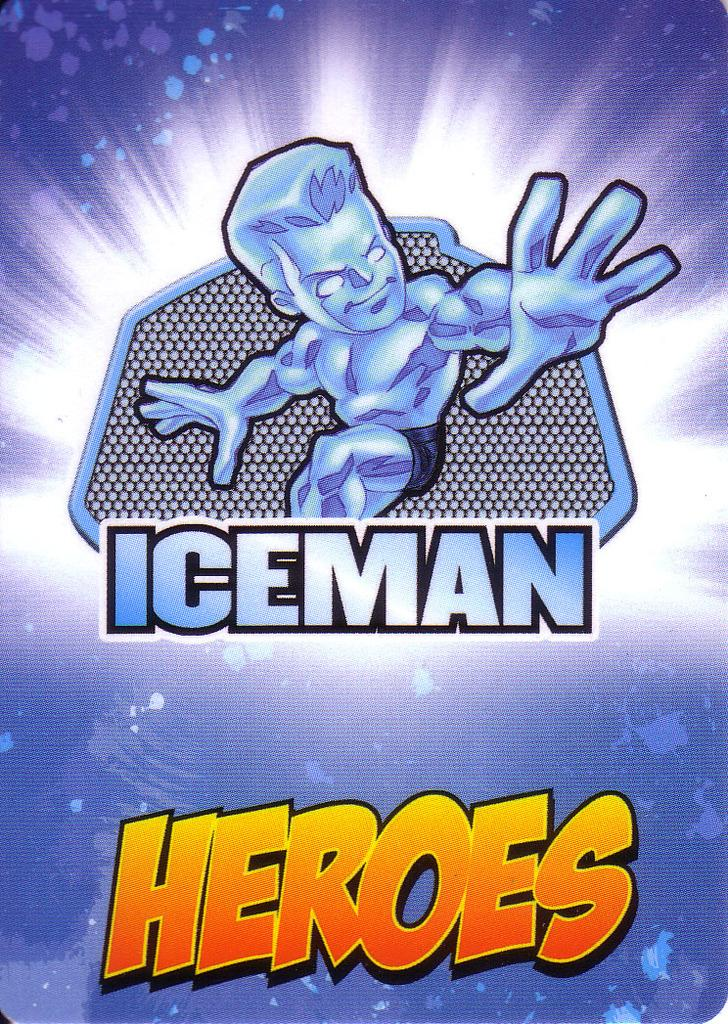<image>
Summarize the visual content of the image. Blue  and white comic book cover titled Iceman Heros. 